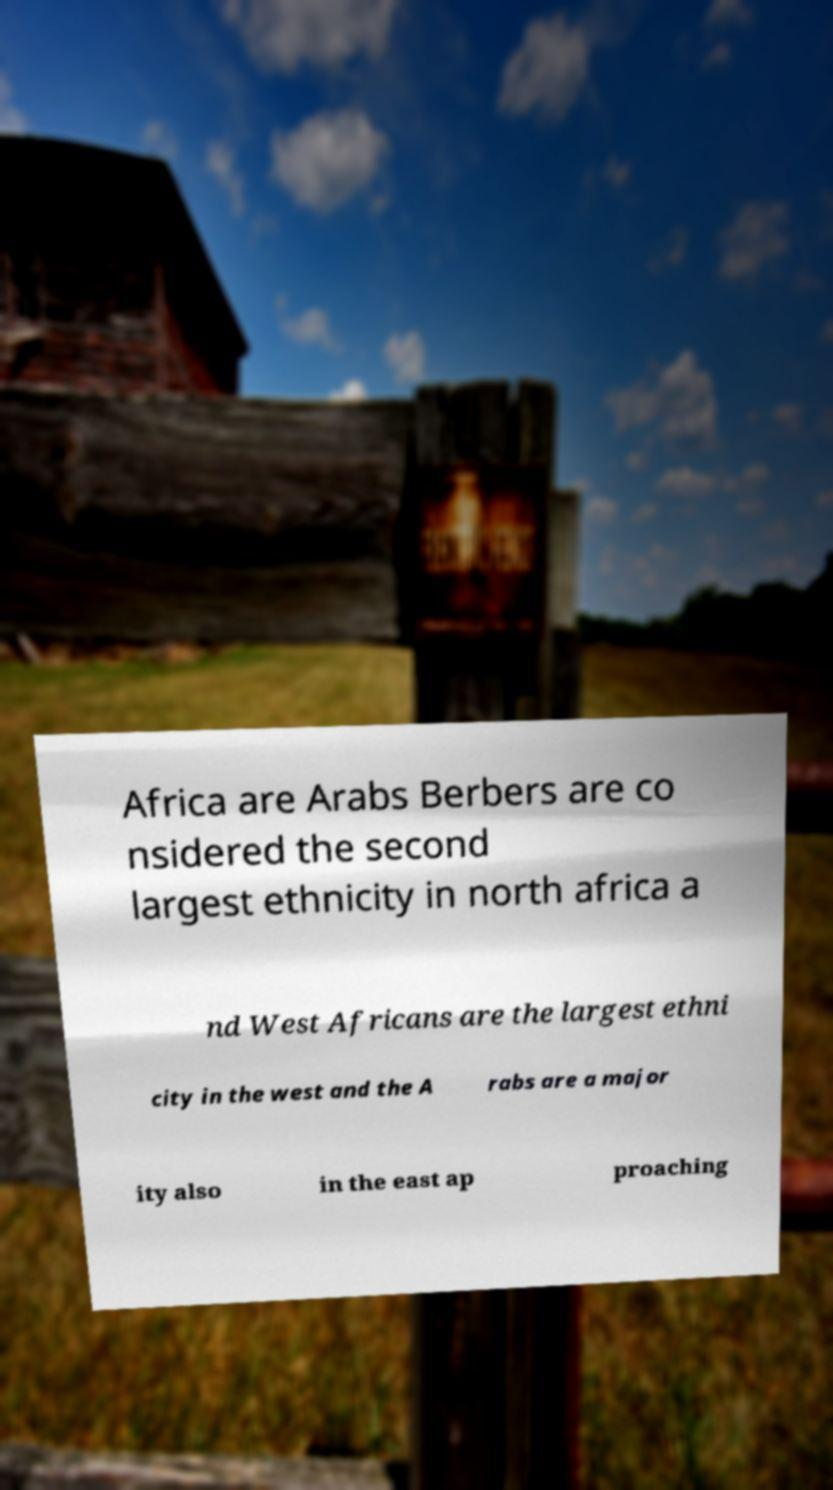What messages or text are displayed in this image? I need them in a readable, typed format. Africa are Arabs Berbers are co nsidered the second largest ethnicity in north africa a nd West Africans are the largest ethni city in the west and the A rabs are a major ity also in the east ap proaching 